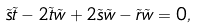Convert formula to latex. <formula><loc_0><loc_0><loc_500><loc_500>\tilde { s } \tilde { t } - 2 \tilde { t } \tilde { w } + 2 \tilde { s } \tilde { w } - \tilde { r } \tilde { w } = 0 ,</formula> 